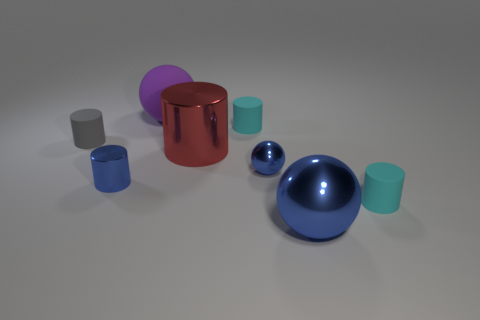What number of objects are the same color as the small metallic sphere?
Your response must be concise. 2. Do the small shiny cylinder and the metallic sphere that is left of the large shiny sphere have the same color?
Keep it short and to the point. Yes. The blue metallic thing that is the same shape as the red metal object is what size?
Provide a short and direct response. Small. Does the cyan cylinder in front of the red cylinder have the same size as the shiny cylinder right of the blue metal cylinder?
Offer a terse response. No. Is the small metallic cylinder the same color as the big metal ball?
Offer a very short reply. Yes. There is a cyan matte cylinder on the right side of the big blue metal object that is on the right side of the big red object; what number of large things are behind it?
Ensure brevity in your answer.  2. There is a big blue thing that is in front of the ball on the left side of the red cylinder to the right of the small metal cylinder; what is its shape?
Offer a very short reply. Sphere. How many other things are the same color as the tiny metallic cylinder?
Offer a terse response. 2. The blue object in front of the cyan cylinder to the right of the large blue ball is what shape?
Give a very brief answer. Sphere. What number of red metal cylinders are behind the tiny gray matte cylinder?
Your response must be concise. 0. 